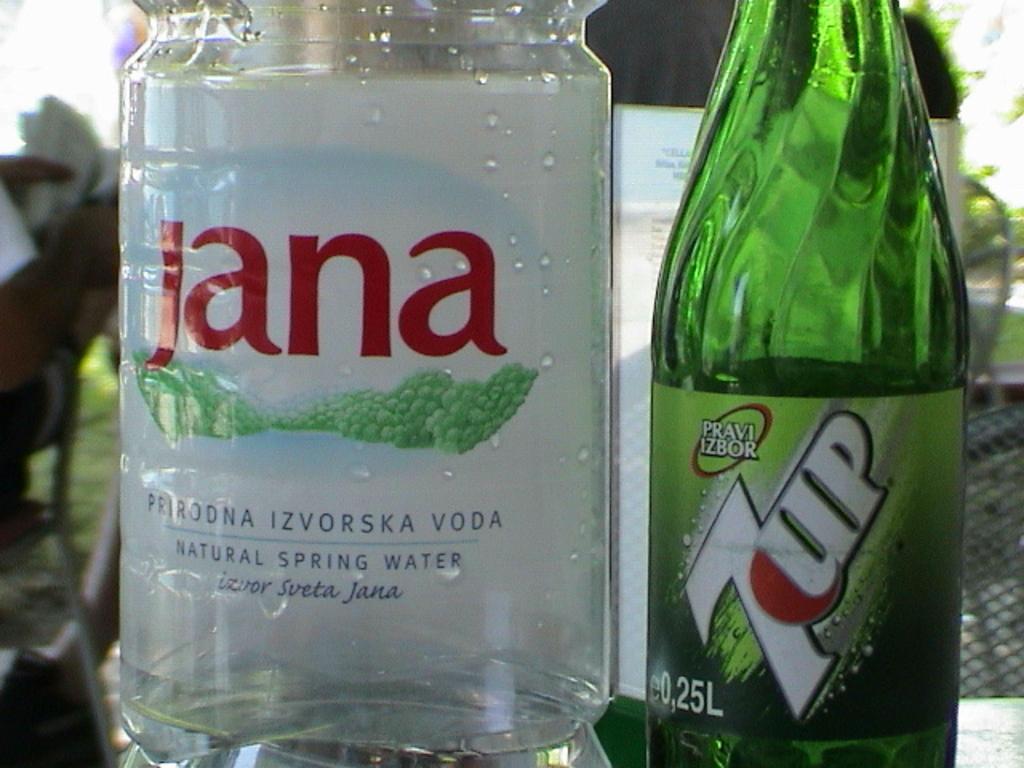What is the name of the beverage in the green bottle?
Give a very brief answer. 7up. What type of liquor is in the clear bottle?
Give a very brief answer. Jana. 